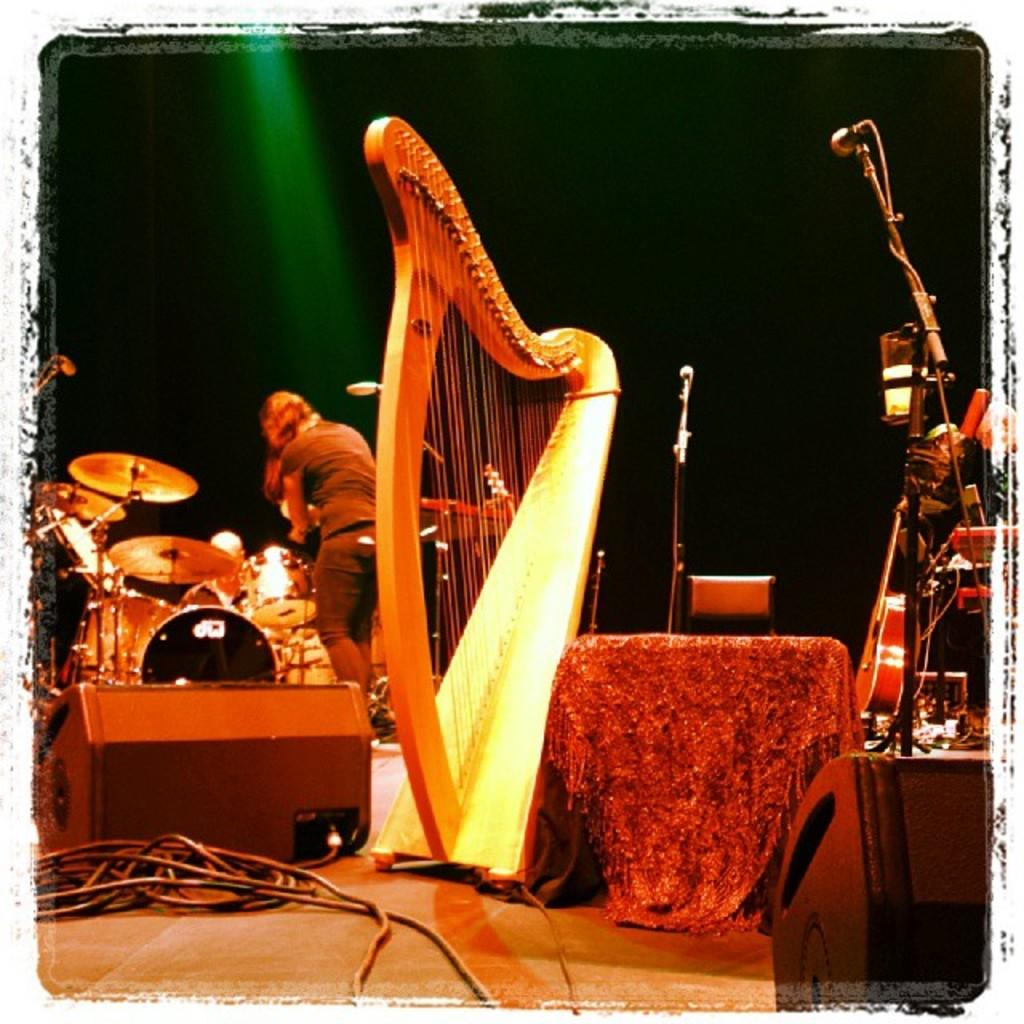What is happening on the stage in the image? There is a person on the stage in the image. What is the person doing on the stage? The person has musical instruments around them, suggesting they are playing or preparing to play music. What equipment is visible in the image for amplifying sound? There is a microphone and a microphone stand in the image. What type of scent can be detected in the image? There is no mention of any scent in the image, so it cannot be determined from the picture. 